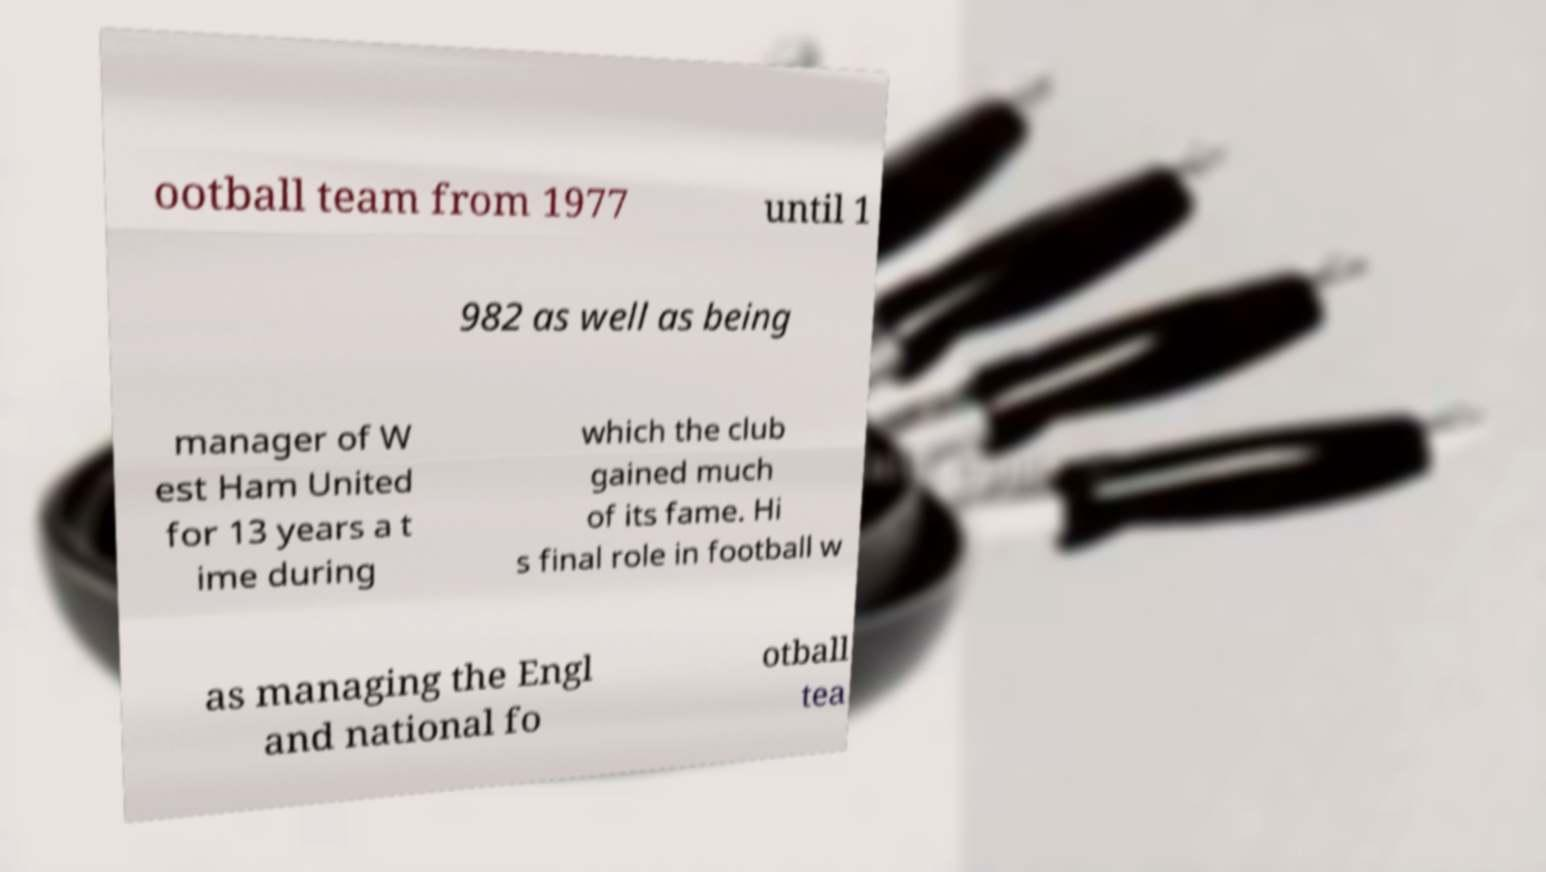Could you extract and type out the text from this image? ootball team from 1977 until 1 982 as well as being manager of W est Ham United for 13 years a t ime during which the club gained much of its fame. Hi s final role in football w as managing the Engl and national fo otball tea 